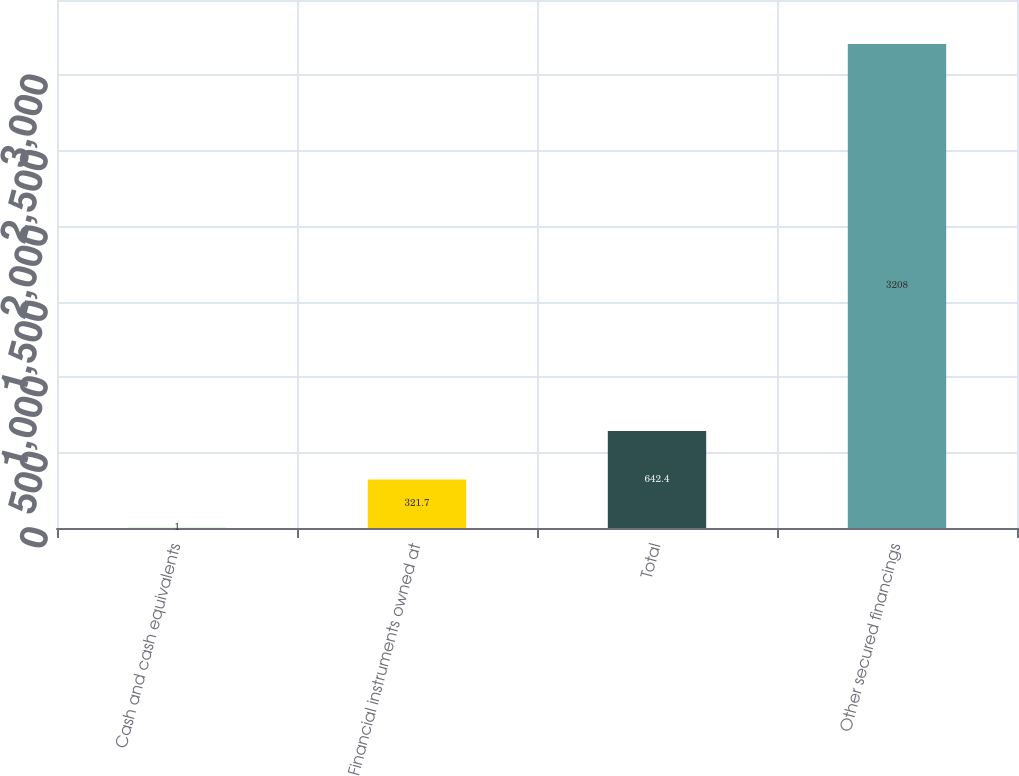<chart> <loc_0><loc_0><loc_500><loc_500><bar_chart><fcel>Cash and cash equivalents<fcel>Financial instruments owned at<fcel>Total<fcel>Other secured financings<nl><fcel>1<fcel>321.7<fcel>642.4<fcel>3208<nl></chart> 